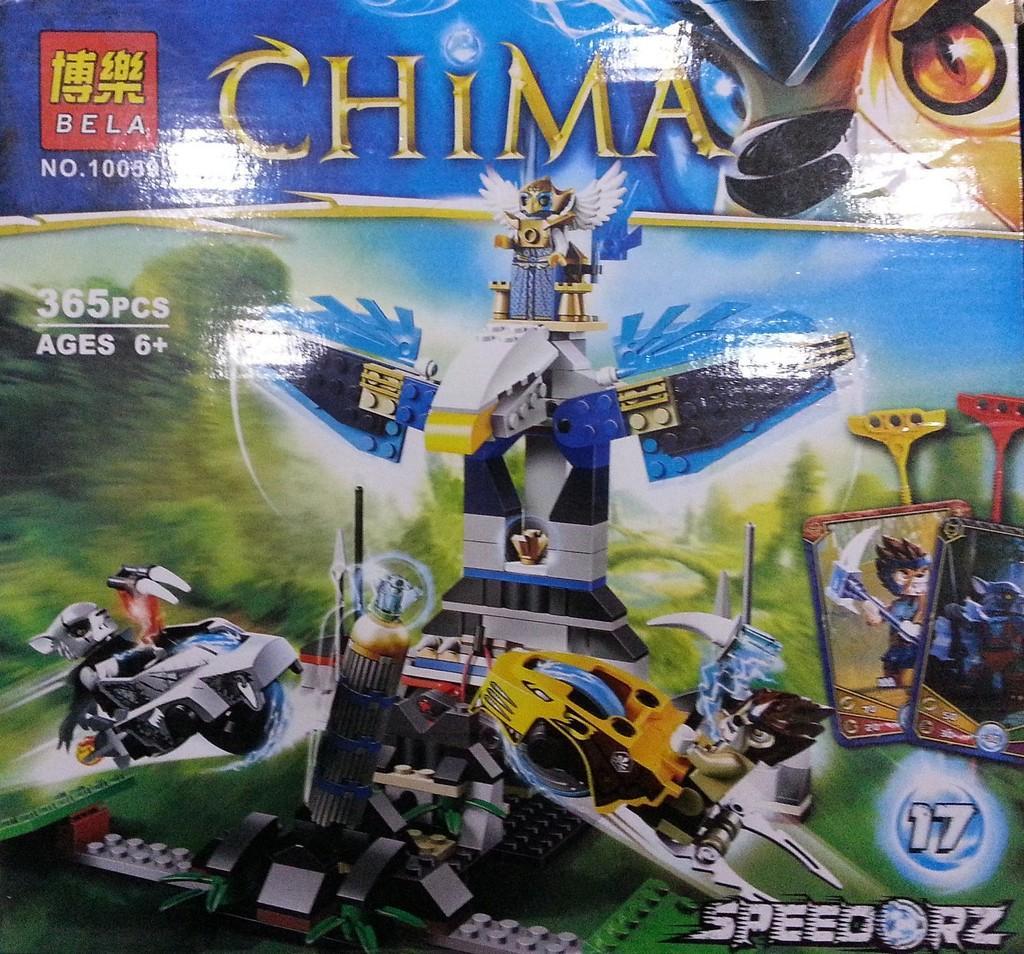In one or two sentences, can you explain what this image depicts? In this picture we can see a poster and on the poster there are machines and it is written as "China". 